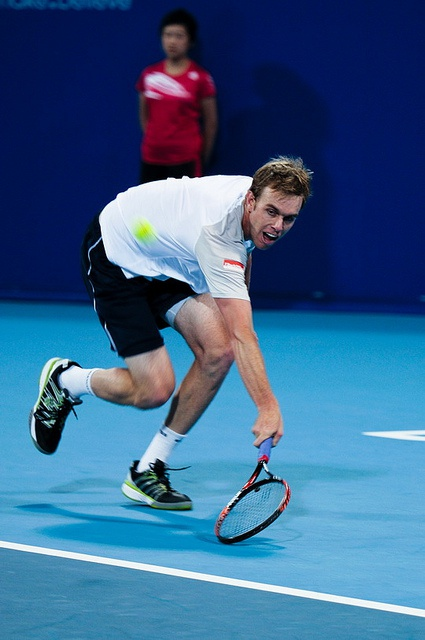Describe the objects in this image and their specific colors. I can see people in navy, lightgray, black, and gray tones, people in navy, maroon, black, and brown tones, tennis racket in navy, lightblue, black, and teal tones, and sports ball in navy, lightgreen, and beige tones in this image. 